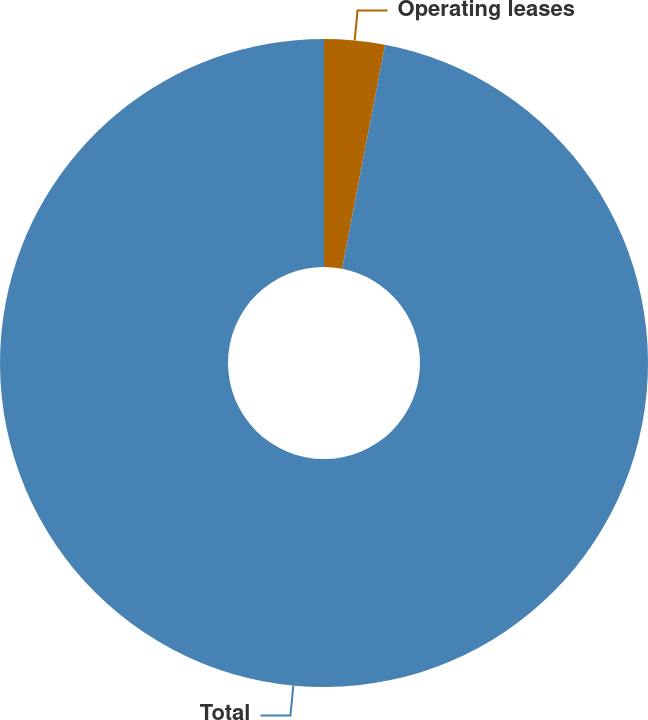Convert chart to OTSL. <chart><loc_0><loc_0><loc_500><loc_500><pie_chart><fcel>Operating leases<fcel>Total<nl><fcel>3.02%<fcel>96.98%<nl></chart> 